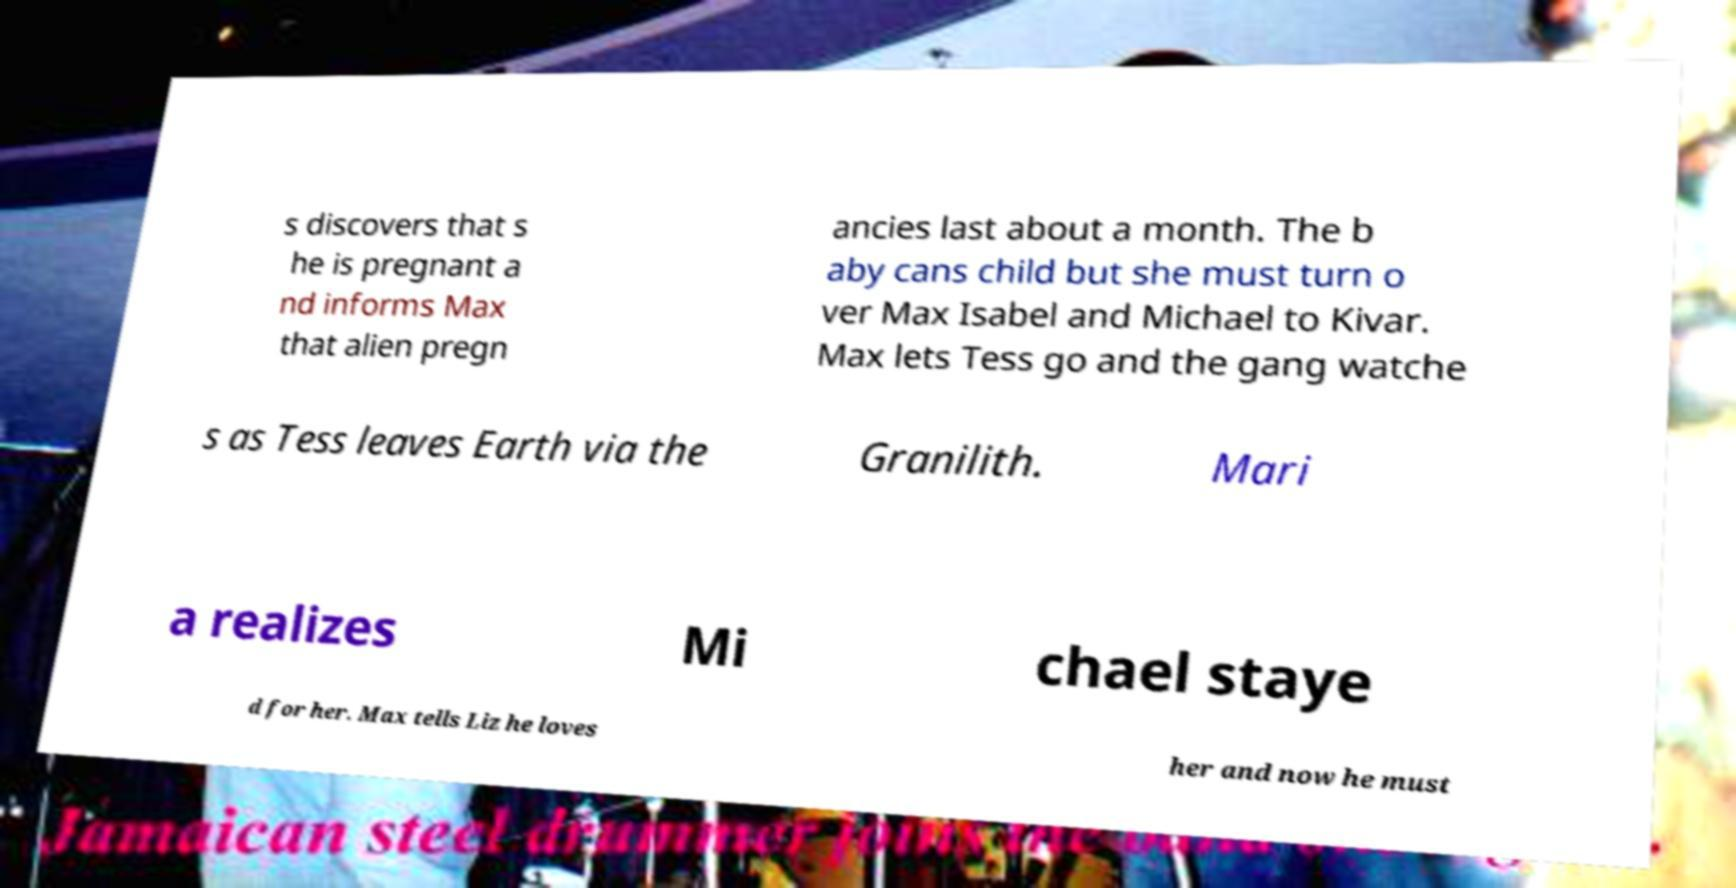There's text embedded in this image that I need extracted. Can you transcribe it verbatim? s discovers that s he is pregnant a nd informs Max that alien pregn ancies last about a month. The b aby cans child but she must turn o ver Max Isabel and Michael to Kivar. Max lets Tess go and the gang watche s as Tess leaves Earth via the Granilith. Mari a realizes Mi chael staye d for her. Max tells Liz he loves her and now he must 